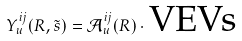Convert formula to latex. <formula><loc_0><loc_0><loc_500><loc_500>Y _ { u } ^ { i j } ( R , \tilde { s } ) = \mathcal { A } _ { u } ^ { i j } ( R ) \cdot \text {VEVs}</formula> 